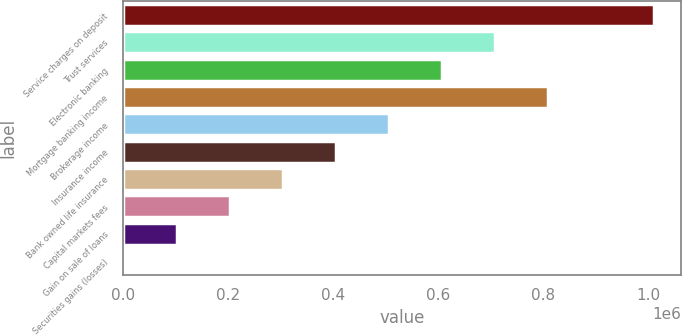<chart> <loc_0><loc_0><loc_500><loc_500><bar_chart><fcel>Service charges on deposit<fcel>Trust services<fcel>Electronic banking<fcel>Mortgage banking income<fcel>Brokerage income<fcel>Insurance income<fcel>Bank owned life insurance<fcel>Capital markets fees<fcel>Gain on sale of loans<fcel>Securities gains (losses)<nl><fcel>1.0122e+06<fcel>708663<fcel>607485<fcel>809840<fcel>506307<fcel>405129<fcel>303951<fcel>202774<fcel>101596<fcel>418<nl></chart> 